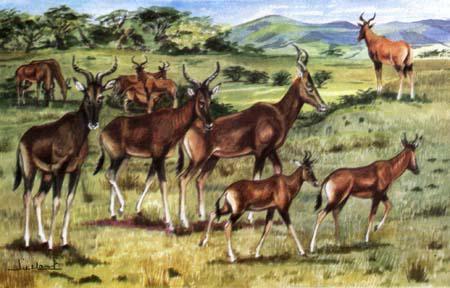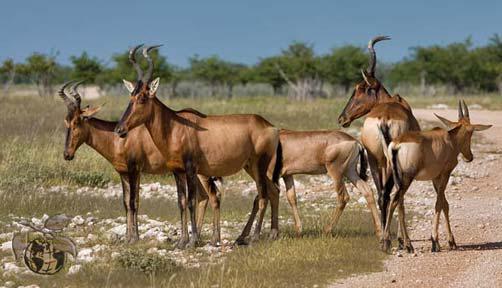The first image is the image on the left, the second image is the image on the right. Analyze the images presented: Is the assertion "The sky can not be seen in the image on the left." valid? Answer yes or no. No. 